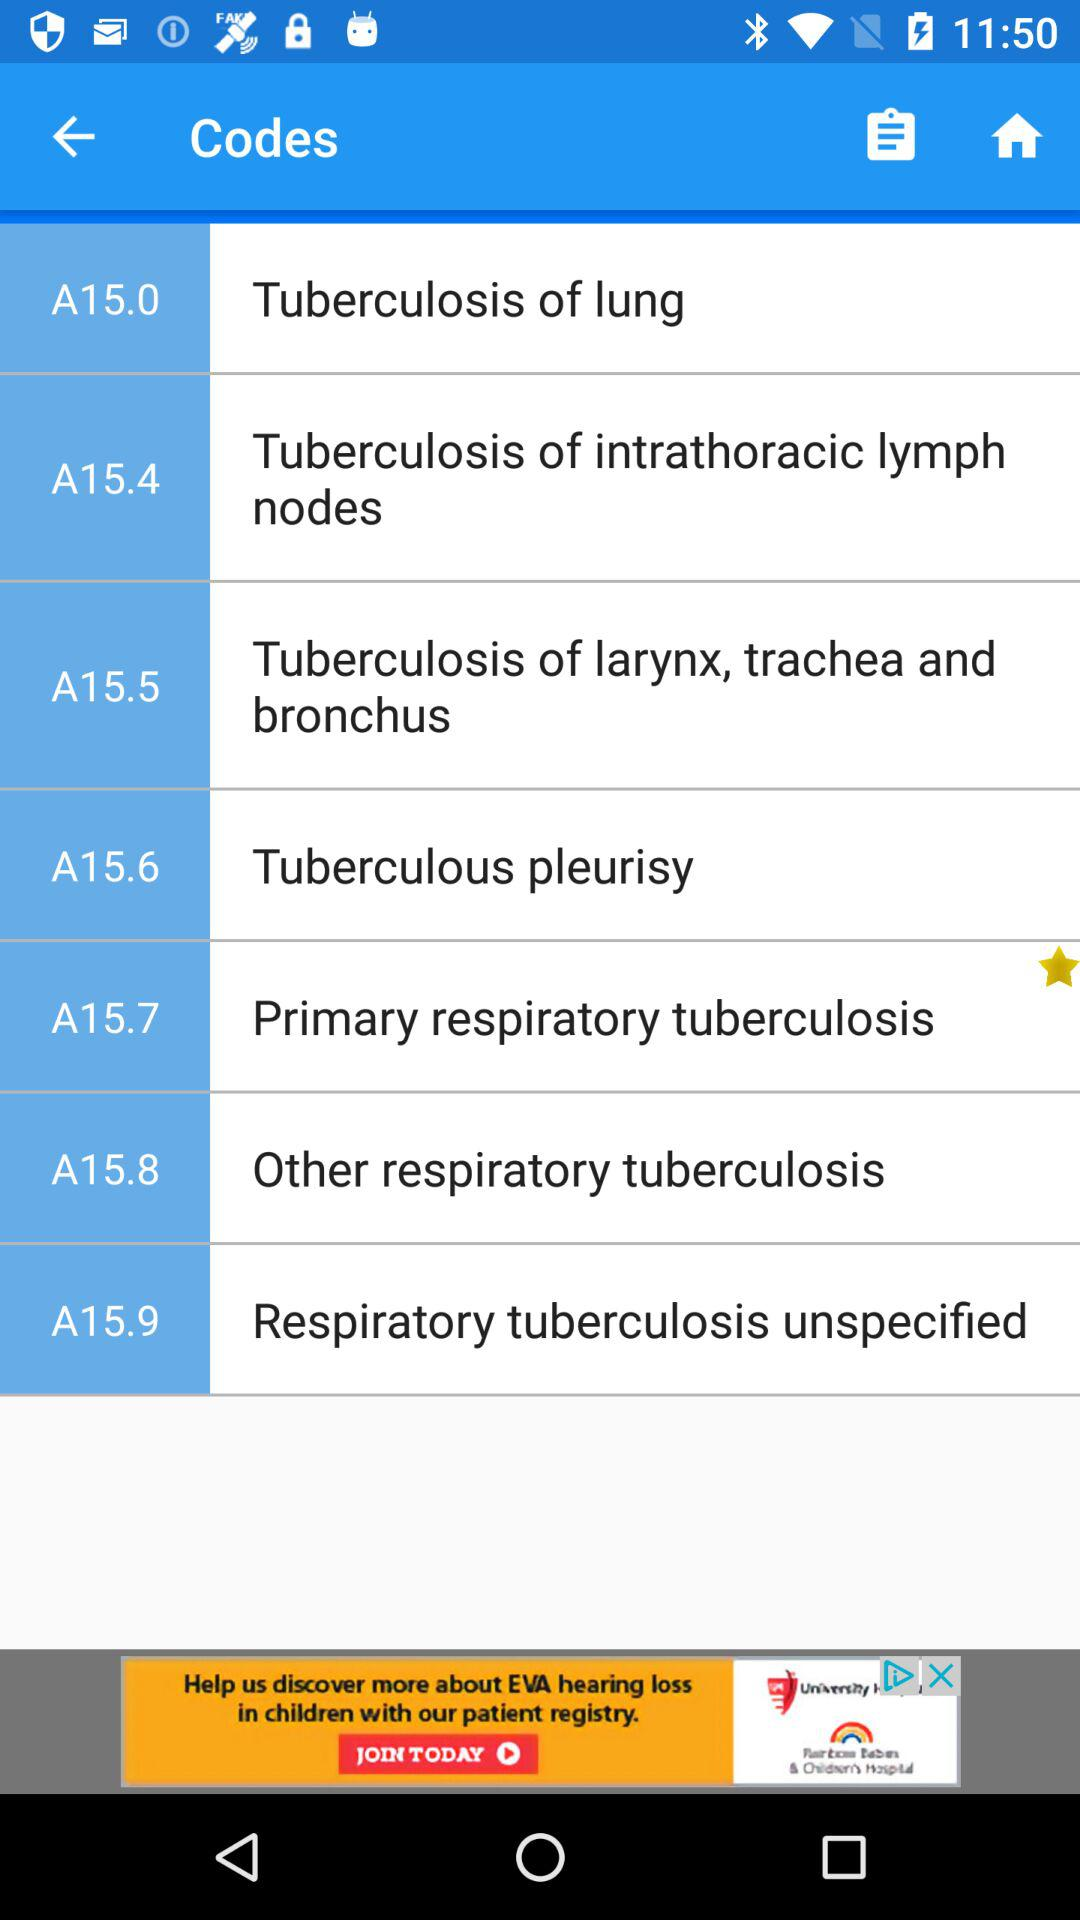What code is starred? The starred code is A15.7, which is primary respiratory tuberculosis. 